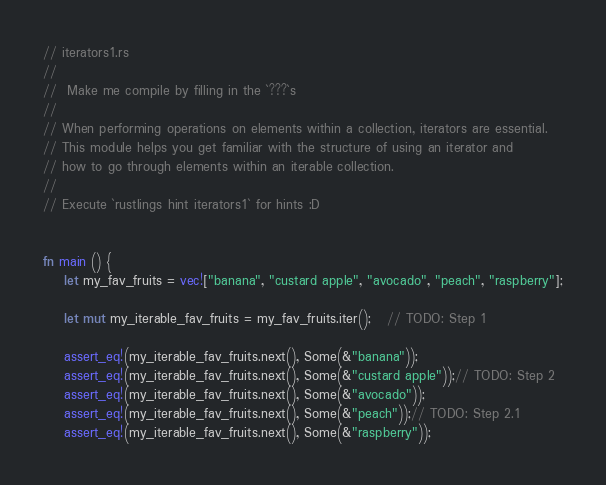Convert code to text. <code><loc_0><loc_0><loc_500><loc_500><_Rust_>// iterators1.rs
// 
//  Make me compile by filling in the `???`s
//
// When performing operations on elements within a collection, iterators are essential.
// This module helps you get familiar with the structure of using an iterator and 
// how to go through elements within an iterable collection.
// 
// Execute `rustlings hint iterators1` for hints :D


fn main () {
    let my_fav_fruits = vec!["banana", "custard apple", "avocado", "peach", "raspberry"];

    let mut my_iterable_fav_fruits = my_fav_fruits.iter();   // TODO: Step 1

    assert_eq!(my_iterable_fav_fruits.next(), Some(&"banana"));
    assert_eq!(my_iterable_fav_fruits.next(), Some(&"custard apple"));// TODO: Step 2
    assert_eq!(my_iterable_fav_fruits.next(), Some(&"avocado"));
    assert_eq!(my_iterable_fav_fruits.next(), Some(&"peach"));// TODO: Step 2.1
    assert_eq!(my_iterable_fav_fruits.next(), Some(&"raspberry"));</code> 